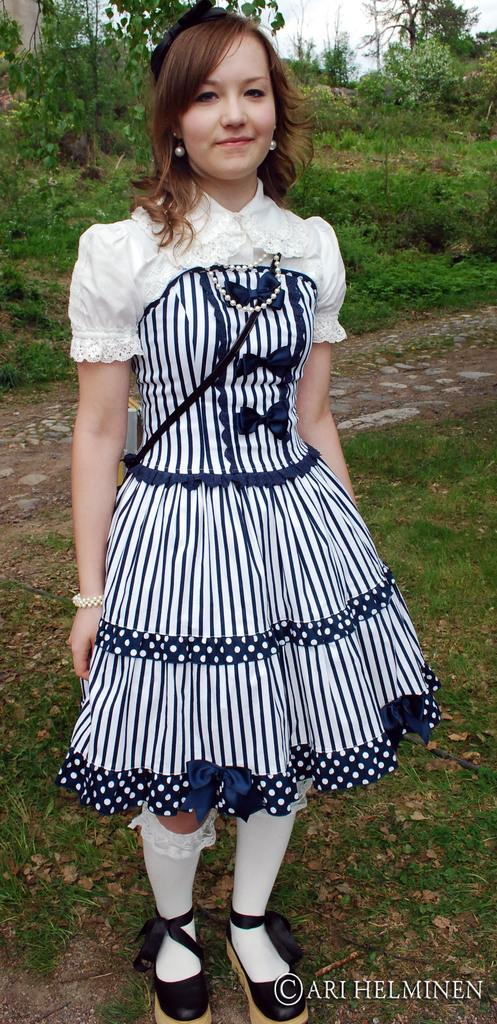Who is the main subject in the image? There is a woman standing in the middle of the image. What is the woman doing in the image? The woman is smiling. What type of vegetation is visible behind the woman? There are trees and grass behind the woman. What is visible at the top of the image? The sky is visible at the top of the image. Can you see a zebra blowing bubbles in the image? No, there is no zebra or bubbles present in the image. 